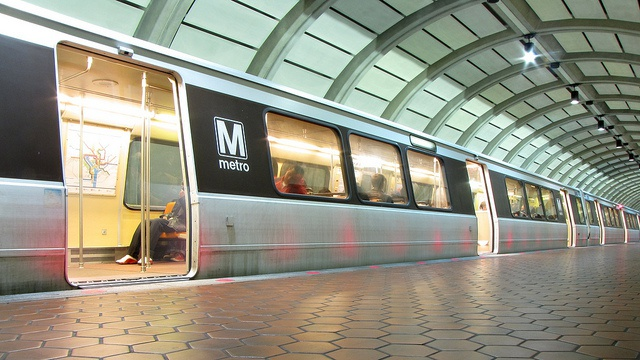Describe the objects in this image and their specific colors. I can see train in white, darkgray, gray, and black tones, people in white, gray, and black tones, people in white, brown, and maroon tones, and people in white, gray, and tan tones in this image. 